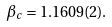Convert formula to latex. <formula><loc_0><loc_0><loc_500><loc_500>\beta _ { c } = 1 . 1 6 0 9 ( 2 ) .</formula> 